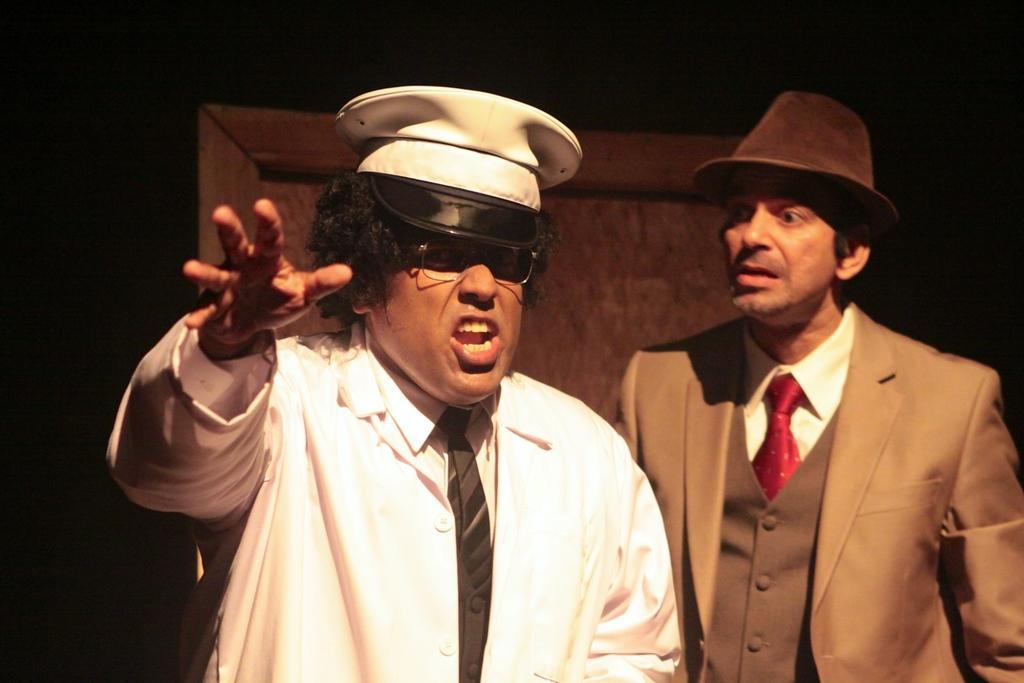Could you give a brief overview of what you see in this image? This picture might be taken inside the room. In this image, in the middle, we can see a man wearing a white color dress is stunning. On the right side, we can also see another man is standing. In the background, we can see a wood wall and black color. 